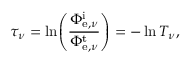Convert formula to latex. <formula><loc_0><loc_0><loc_500><loc_500>\tau _ { \nu } = \ln \, \left ( { \frac { \Phi _ { e , \nu } ^ { i } } { \Phi _ { e , \nu } ^ { t } } } \right ) = - \ln T _ { \nu } ,</formula> 